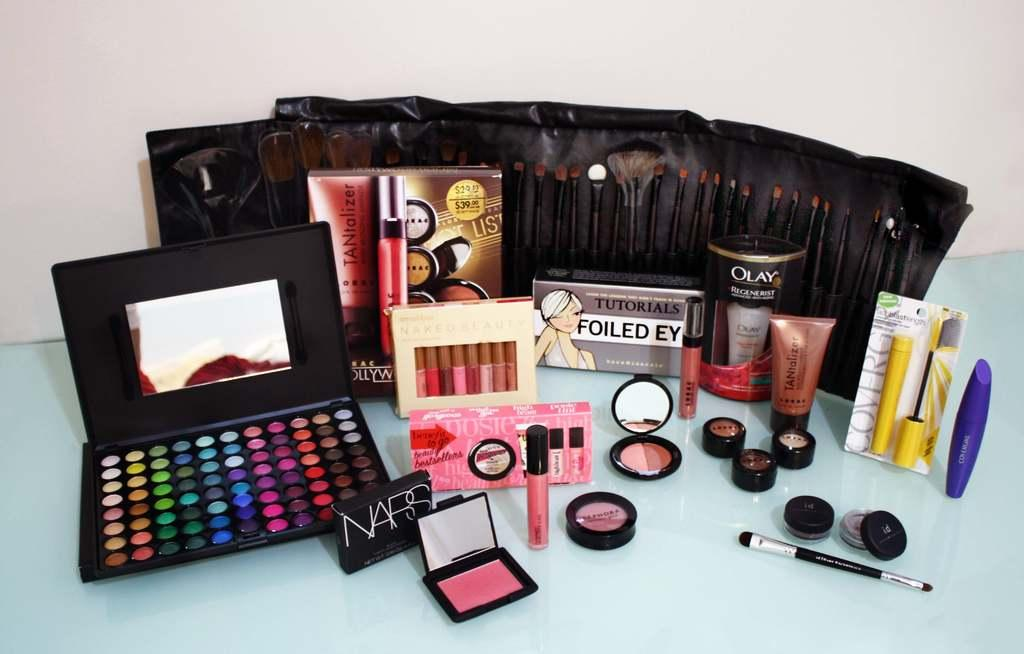<image>
Share a concise interpretation of the image provided. A wide range of makeup items and tools including one from NARS. 